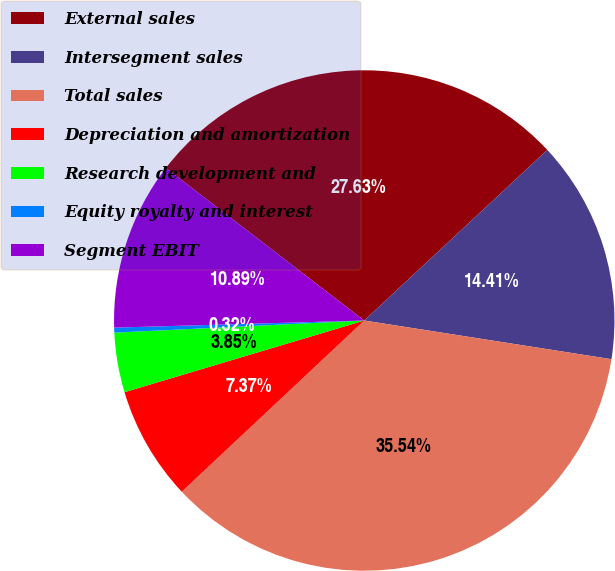<chart> <loc_0><loc_0><loc_500><loc_500><pie_chart><fcel>External sales<fcel>Intersegment sales<fcel>Total sales<fcel>Depreciation and amortization<fcel>Research development and<fcel>Equity royalty and interest<fcel>Segment EBIT<nl><fcel>27.63%<fcel>14.41%<fcel>35.54%<fcel>7.37%<fcel>3.85%<fcel>0.32%<fcel>10.89%<nl></chart> 